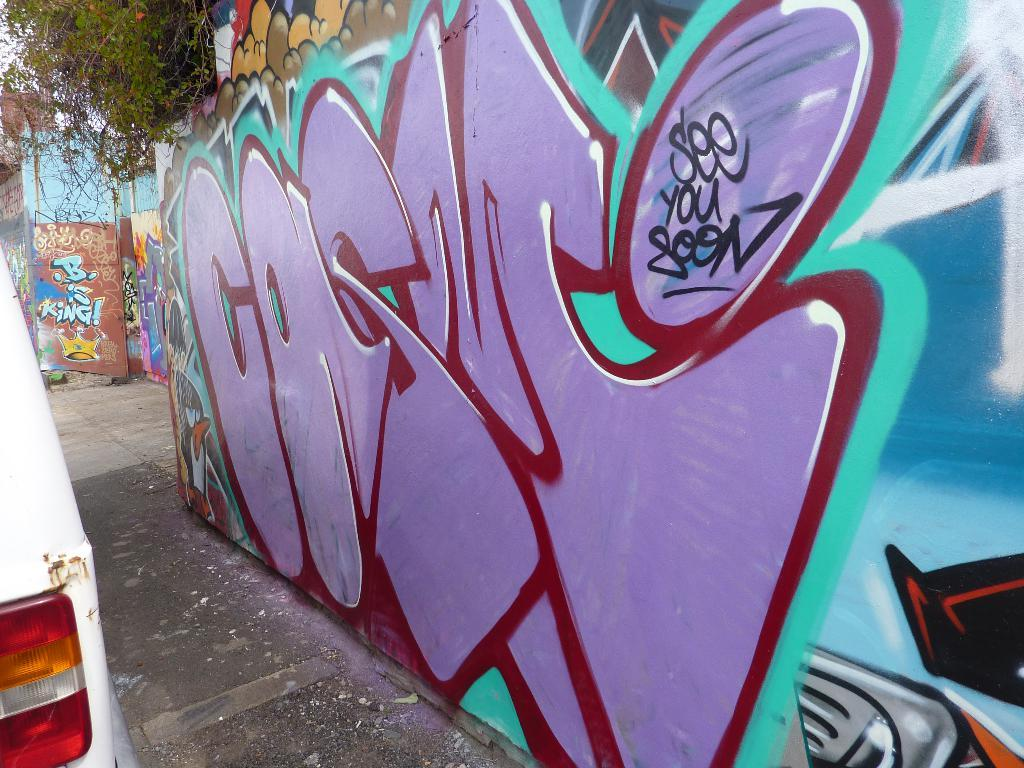What is on the wall in the image? There is a painted wall with text in the image. What else can be seen in the image besides the painted wall? There is a vehicle and a tree in the image. What type of nail is being hammered into the tree in the image? There is no nail being hammered into the tree in the image; it only shows a tree, a painted wall with text, and a vehicle. 